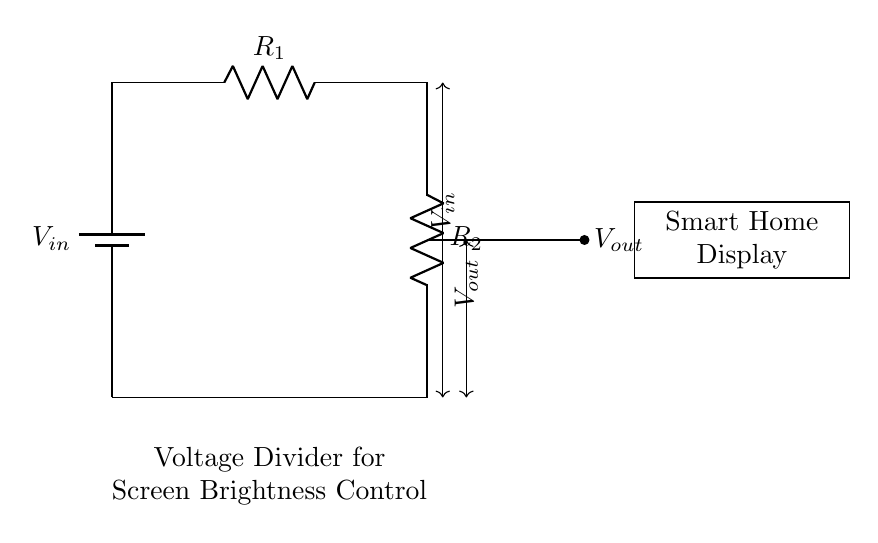What is the type of circuit shown? The circuit is a voltage divider circuit as indicated by the arrangement of the resistors and the input/output voltage configuration.
Answer: Voltage divider What are the two resistors labeled in the circuit? The two resistors in the voltage divider circuit are labeled R1 and R2.
Answer: R1 and R2 What does Vout represent in this circuit? Vout represents the output voltage that is taken from the junction between the two resistors in the voltage divider.
Answer: Output voltage How does the configuration of the resistors affect the brightness? The brightness is adjusted by changing the resistance values, which alters Vout; higher resistance leads to lower output voltage, thus dimmer brightness.
Answer: Changes resistance If the input voltage is 12 volts, what is the function of the circuit? The function of the circuit is to lower the voltage from the input (12 volts) to a voltage suitable for controlling the brightness of the smart home display.
Answer: Voltage adjustment Why is a voltage divider specifically suitable for screen brightness control? A voltage divider is suitable because it allows for a simple and effective way to adjust voltage levels, which correspond to brightness levels on the display.
Answer: Voltage adjustment technique What is the relationship between Vout and Vin in this circuit? The relationship is that Vout is a fraction of Vin determined by the values of R1 and R2 as per the voltage divider formula, Vout = Vin * (R2 / (R1 + R2)).
Answer: Fractional relation 